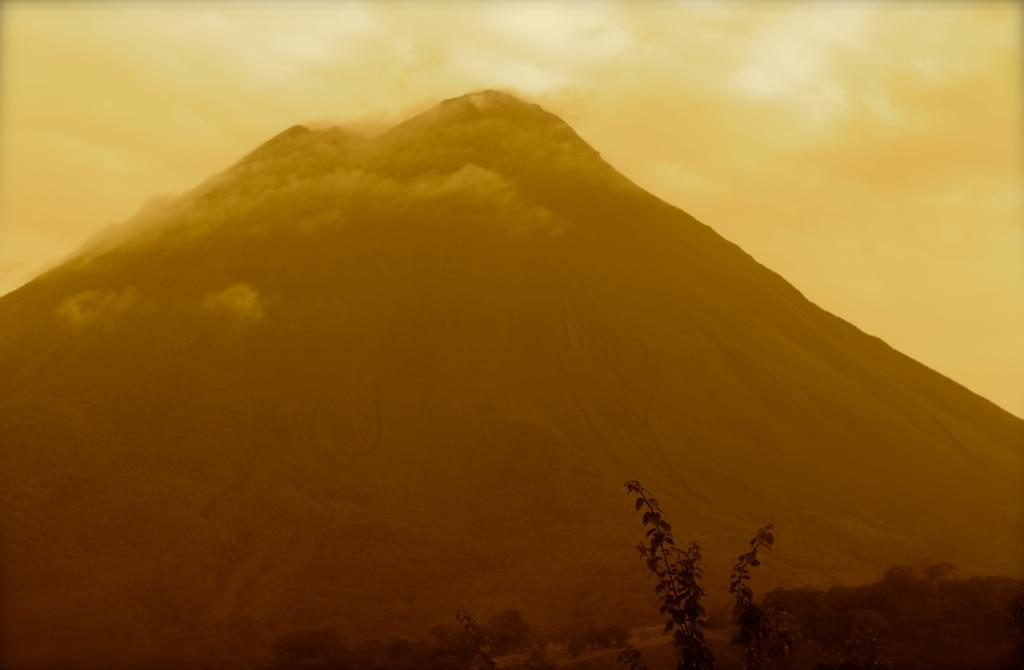What geographical feature is the main subject of the image? There is a mountain in the image. What is happening to the mountain in the image? Clouds are passing over the mountain. What type of vegetation can be seen in the image? There are trees and plants visible in the image. What invention is being used by the dog in the image? There is no dog or invention present in the image. 